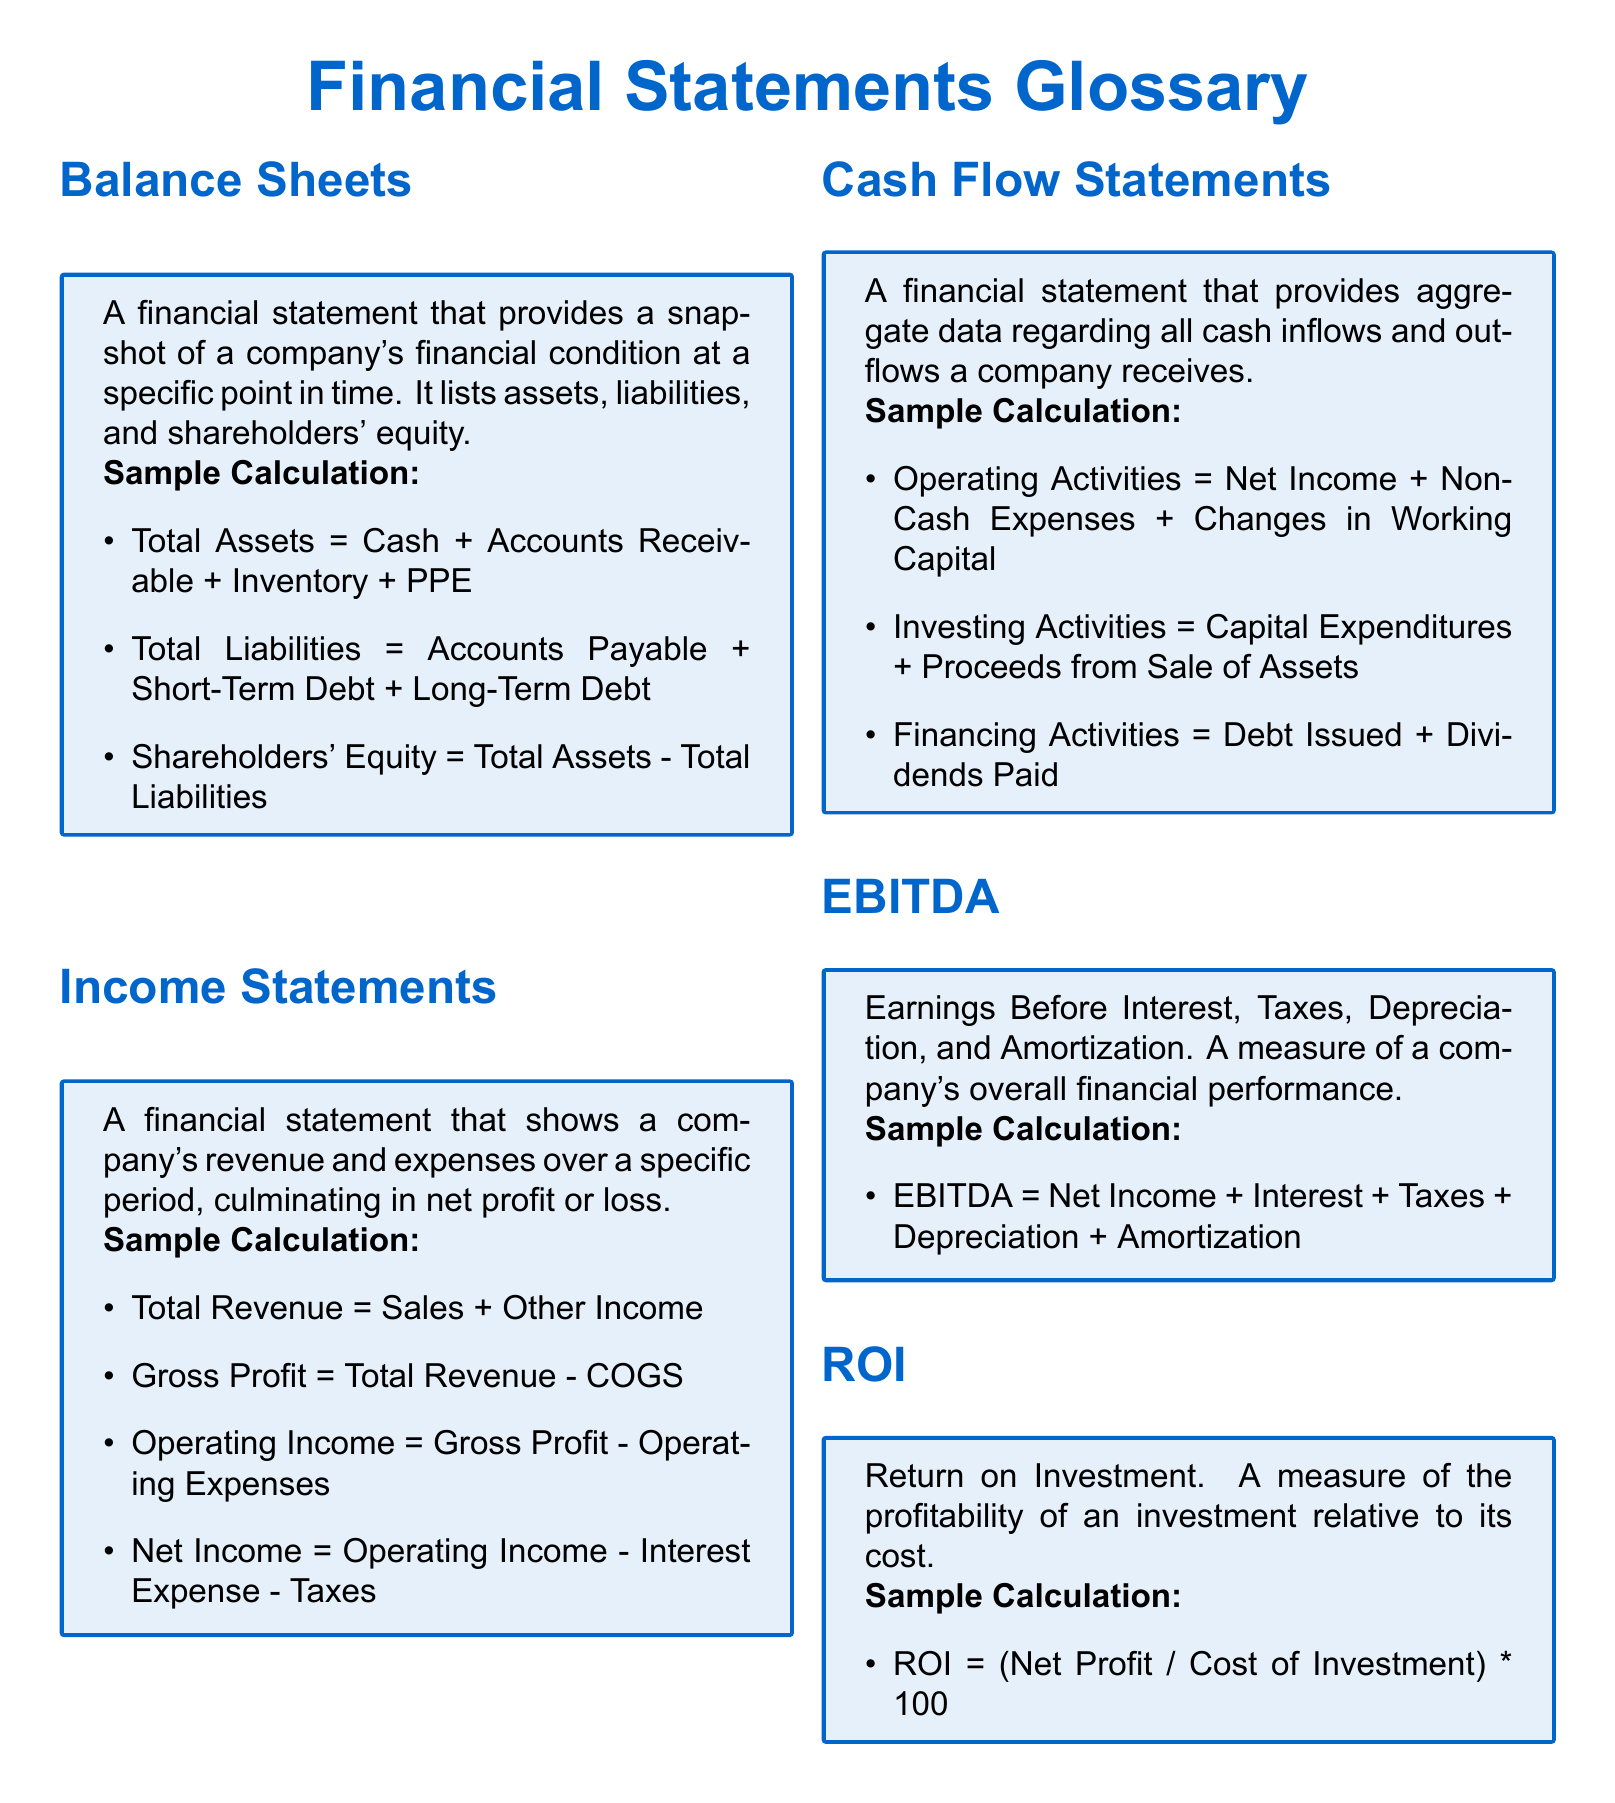What is a balance sheet? A balance sheet is defined in the document as a financial statement that provides a snapshot of a company's financial condition at a specific point in time.
Answer: financial statement What does EBITDA stand for? The acronym EBITDA is explained in the document as Earnings Before Interest, Taxes, Depreciation, and Amortization.
Answer: Earnings Before Interest, Taxes, Depreciation, and Amortization How is net income calculated? The document explains that net income is calculated as Operating Income minus Interest Expense and Taxes.
Answer: Operating Income minus Interest Expense and Taxes What components are included in total liabilities? The document specifies that total liabilities include Accounts Payable, Short-Term Debt, and Long-Term Debt.
Answer: Accounts Payable, Short-Term Debt, and Long-Term Debt What does ROI represent? ROI is defined in the document as a measure of the profitability of an investment relative to its cost.
Answer: measure of profitability What is the formula for operating activities in the cash flow statement? According to the document, the formula for operating activities is Net Income plus Non-Cash Expenses plus Changes in Working Capital.
Answer: Net Income plus Non-Cash Expenses plus Changes in Working Capital What does the income statement show over a specific period? The document states that the income statement shows a company's revenue and expenses over a specific period, culminating in net profit or loss.
Answer: revenue and expenses What are the three main sections of a cash flow statement? The document outlines that cash flow statements consist of Operating Activities, Investing Activities, and Financing Activities.
Answer: Operating Activities, Investing Activities, Financing Activities How is EBITDA calculated? The document shows that EBITDA is calculated as Net Income plus Interest plus Taxes plus Depreciation plus Amortization.
Answer: Net Income plus Interest plus Taxes plus Depreciation plus Amortization 